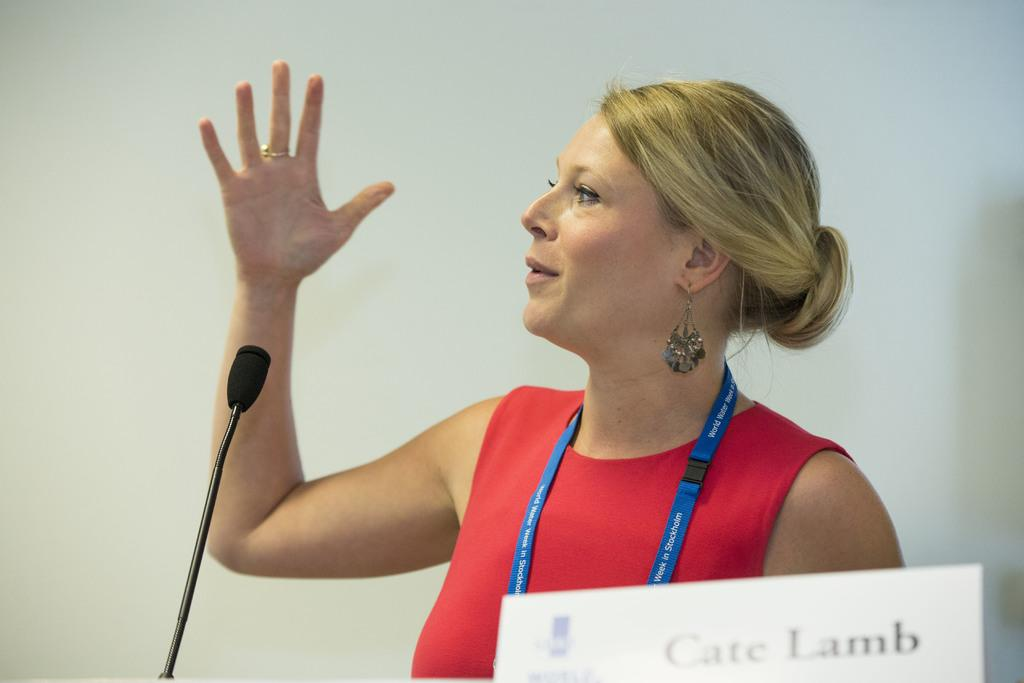Who is the main subject in the image? There is a woman in the image. What is the woman wearing? The woman is wearing a red dress. What object is in front of the woman? There is a microphone and a white colored board in front of the woman. How would you describe the background of the image? The background of the image is white and blurry. Can you see any signs of winter in the image? There is no indication of winter in the image; the background is white but not specifically related to winter. 